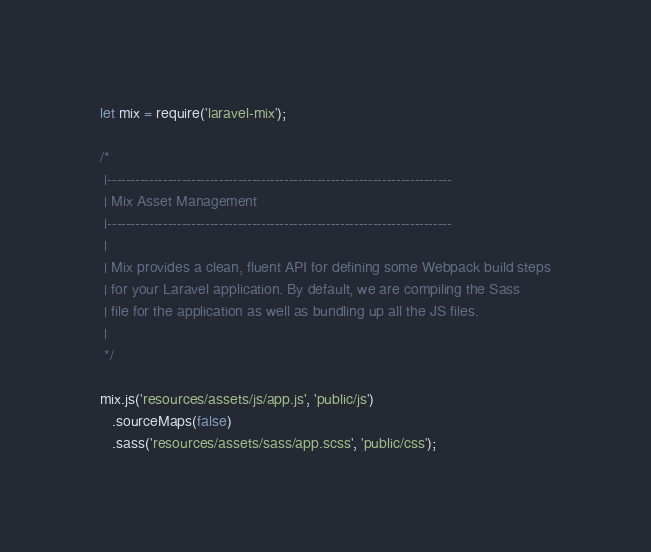<code> <loc_0><loc_0><loc_500><loc_500><_JavaScript_>let mix = require('laravel-mix');

/*
 |--------------------------------------------------------------------------
 | Mix Asset Management
 |--------------------------------------------------------------------------
 |
 | Mix provides a clean, fluent API for defining some Webpack build steps
 | for your Laravel application. By default, we are compiling the Sass
 | file for the application as well as bundling up all the JS files.
 |
 */

mix.js('resources/assets/js/app.js', 'public/js')
   .sourceMaps(false)
   .sass('resources/assets/sass/app.scss', 'public/css');
</code> 